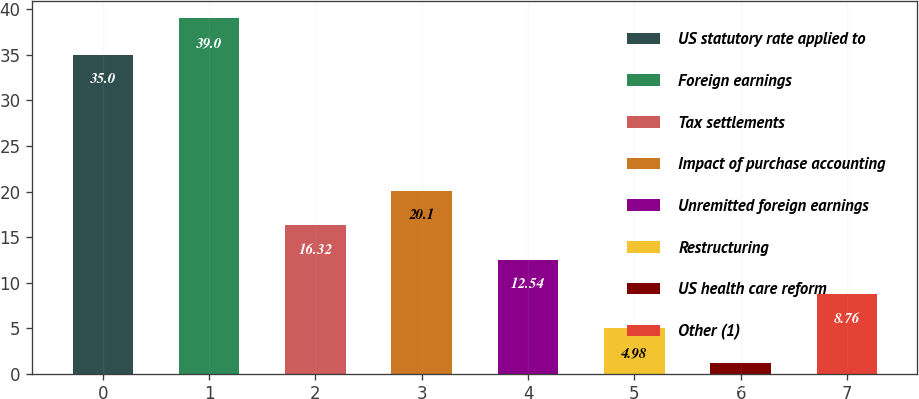Convert chart to OTSL. <chart><loc_0><loc_0><loc_500><loc_500><bar_chart><fcel>US statutory rate applied to<fcel>Foreign earnings<fcel>Tax settlements<fcel>Impact of purchase accounting<fcel>Unremitted foreign earnings<fcel>Restructuring<fcel>US health care reform<fcel>Other (1)<nl><fcel>35<fcel>39<fcel>16.32<fcel>20.1<fcel>12.54<fcel>4.98<fcel>1.2<fcel>8.76<nl></chart> 